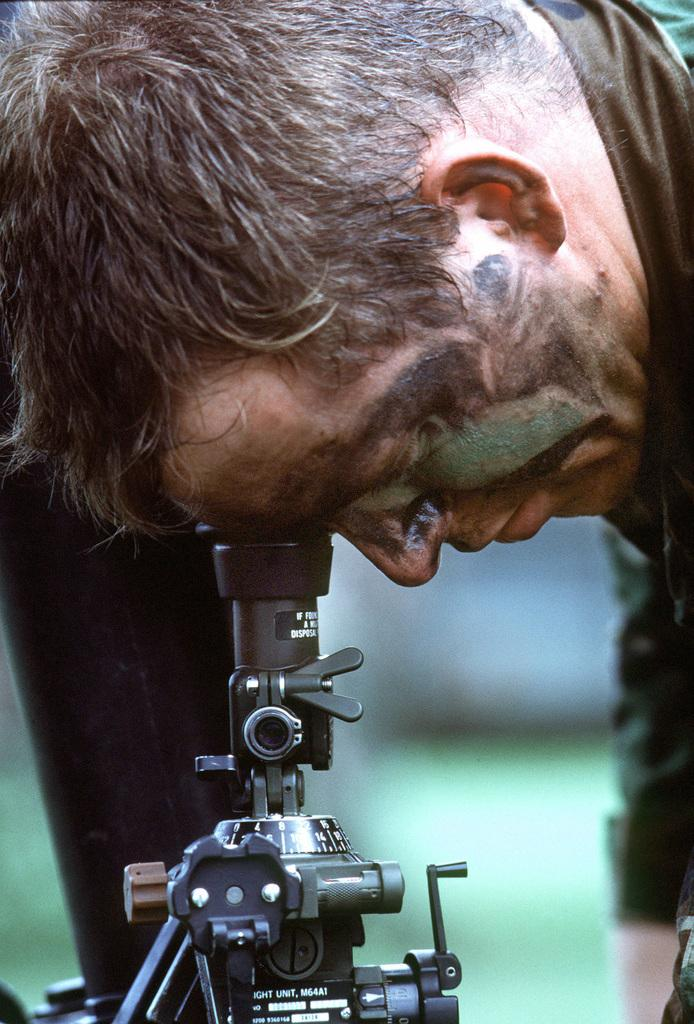What is the main subject of the image? There is a man in the image. What is the man doing in the image? The man is bending and watching through a microscope. Can you describe the background of the image? The background of the image is blurred. What type of advice is the man giving to the arm in the image? There is no arm present in the image, and the man is not giving any advice; he is using a microscope. 